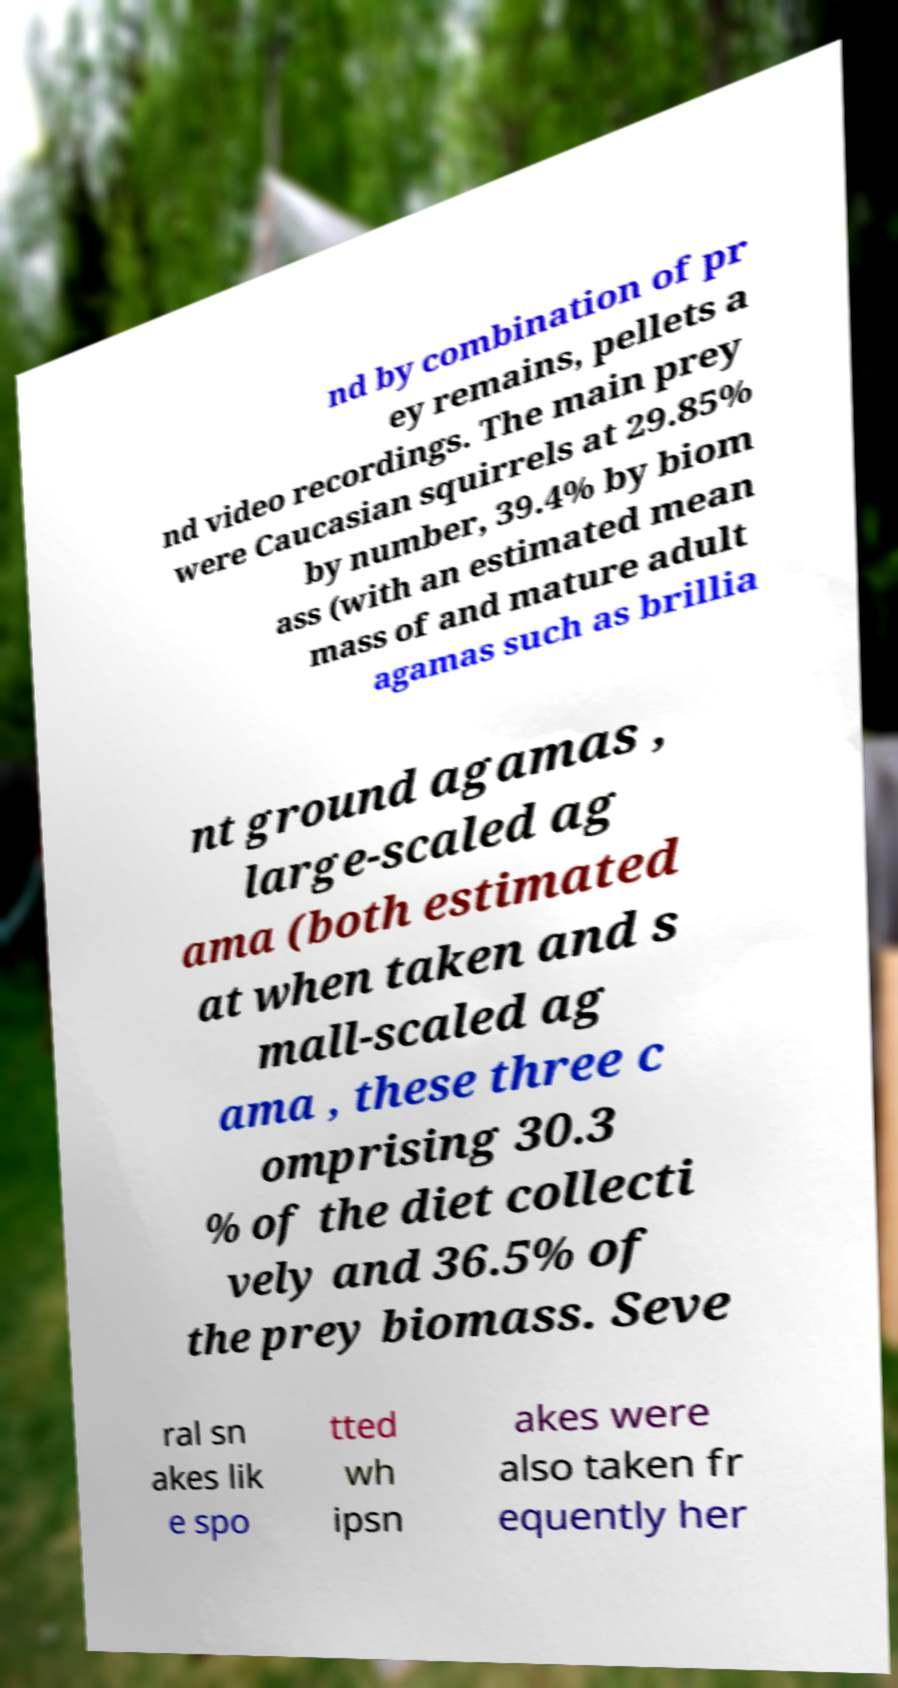What messages or text are displayed in this image? I need them in a readable, typed format. nd by combination of pr ey remains, pellets a nd video recordings. The main prey were Caucasian squirrels at 29.85% by number, 39.4% by biom ass (with an estimated mean mass of and mature adult agamas such as brillia nt ground agamas , large-scaled ag ama (both estimated at when taken and s mall-scaled ag ama , these three c omprising 30.3 % of the diet collecti vely and 36.5% of the prey biomass. Seve ral sn akes lik e spo tted wh ipsn akes were also taken fr equently her 